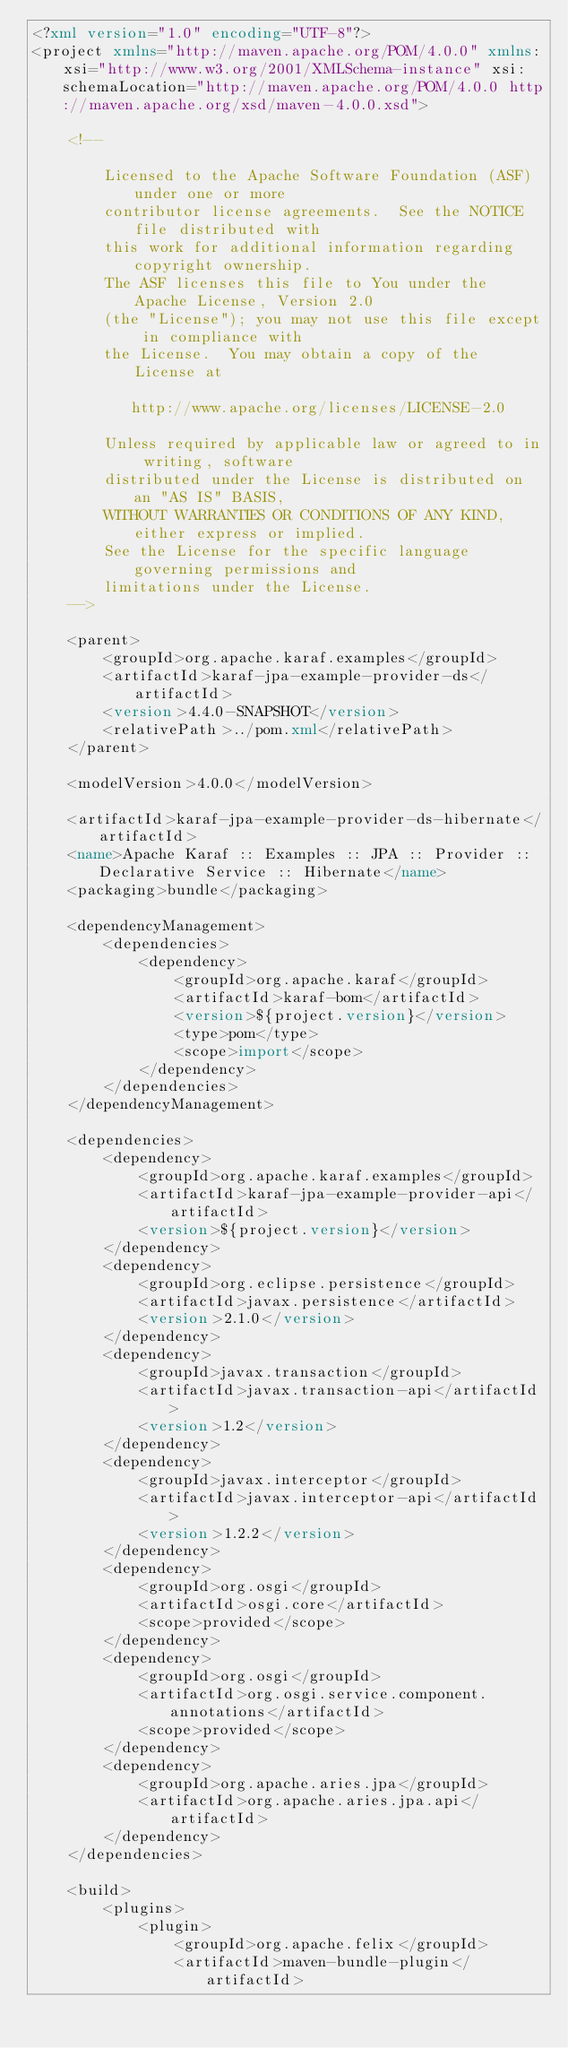<code> <loc_0><loc_0><loc_500><loc_500><_XML_><?xml version="1.0" encoding="UTF-8"?>
<project xmlns="http://maven.apache.org/POM/4.0.0" xmlns:xsi="http://www.w3.org/2001/XMLSchema-instance" xsi:schemaLocation="http://maven.apache.org/POM/4.0.0 http://maven.apache.org/xsd/maven-4.0.0.xsd">

    <!--

        Licensed to the Apache Software Foundation (ASF) under one or more
        contributor license agreements.  See the NOTICE file distributed with
        this work for additional information regarding copyright ownership.
        The ASF licenses this file to You under the Apache License, Version 2.0
        (the "License"); you may not use this file except in compliance with
        the License.  You may obtain a copy of the License at

           http://www.apache.org/licenses/LICENSE-2.0

        Unless required by applicable law or agreed to in writing, software
        distributed under the License is distributed on an "AS IS" BASIS,
        WITHOUT WARRANTIES OR CONDITIONS OF ANY KIND, either express or implied.
        See the License for the specific language governing permissions and
        limitations under the License.
    -->

    <parent>
        <groupId>org.apache.karaf.examples</groupId>
        <artifactId>karaf-jpa-example-provider-ds</artifactId>
        <version>4.4.0-SNAPSHOT</version>
        <relativePath>../pom.xml</relativePath>
    </parent>

    <modelVersion>4.0.0</modelVersion>

    <artifactId>karaf-jpa-example-provider-ds-hibernate</artifactId>
    <name>Apache Karaf :: Examples :: JPA :: Provider :: Declarative Service :: Hibernate</name>
    <packaging>bundle</packaging>

    <dependencyManagement>
        <dependencies>
            <dependency>
                <groupId>org.apache.karaf</groupId>
                <artifactId>karaf-bom</artifactId>
                <version>${project.version}</version>
                <type>pom</type>
                <scope>import</scope>
            </dependency>
        </dependencies>
    </dependencyManagement>

    <dependencies>
        <dependency>
            <groupId>org.apache.karaf.examples</groupId>
            <artifactId>karaf-jpa-example-provider-api</artifactId>
            <version>${project.version}</version>
        </dependency>
        <dependency>
            <groupId>org.eclipse.persistence</groupId>
            <artifactId>javax.persistence</artifactId>
            <version>2.1.0</version>
        </dependency>
        <dependency>
            <groupId>javax.transaction</groupId>
            <artifactId>javax.transaction-api</artifactId>
            <version>1.2</version>
        </dependency>
        <dependency>
            <groupId>javax.interceptor</groupId>
            <artifactId>javax.interceptor-api</artifactId>
            <version>1.2.2</version>
        </dependency>
        <dependency>
            <groupId>org.osgi</groupId>
            <artifactId>osgi.core</artifactId>
            <scope>provided</scope>
        </dependency>
        <dependency>
            <groupId>org.osgi</groupId>
            <artifactId>org.osgi.service.component.annotations</artifactId>
            <scope>provided</scope>
        </dependency>
        <dependency>
            <groupId>org.apache.aries.jpa</groupId>
            <artifactId>org.apache.aries.jpa.api</artifactId>
        </dependency>
    </dependencies>

    <build>
        <plugins>
            <plugin>
                <groupId>org.apache.felix</groupId>
                <artifactId>maven-bundle-plugin</artifactId></code> 